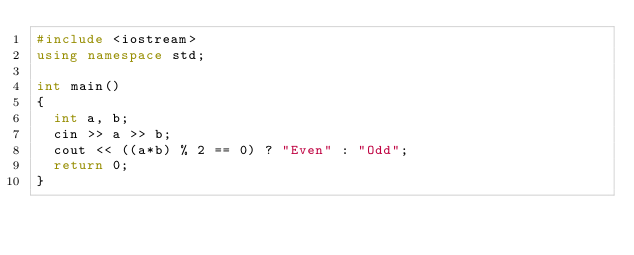<code> <loc_0><loc_0><loc_500><loc_500><_C++_>#include <iostream>
using namespace std;
 
int main()
{
	int a, b;
  cin >> a >> b;
  cout << ((a*b) % 2 == 0) ? "Even" : "Odd";
  return 0;
}</code> 